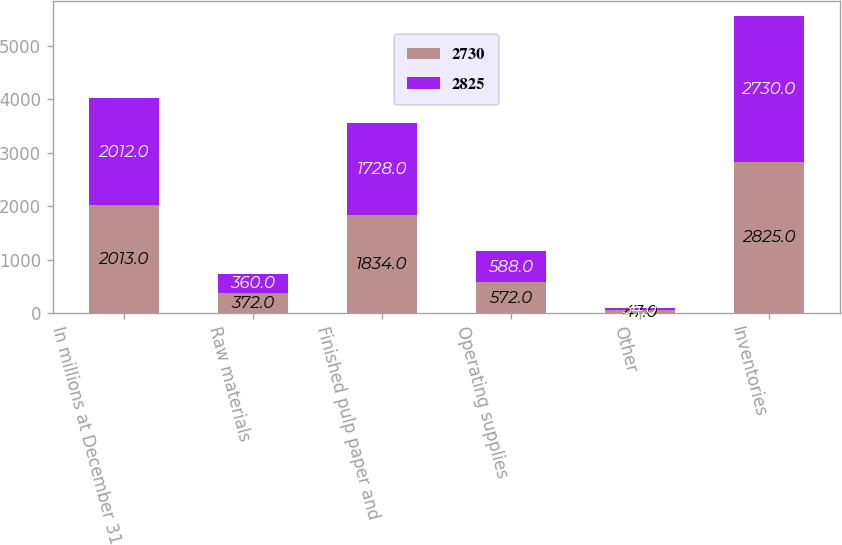Convert chart. <chart><loc_0><loc_0><loc_500><loc_500><stacked_bar_chart><ecel><fcel>In millions at December 31<fcel>Raw materials<fcel>Finished pulp paper and<fcel>Operating supplies<fcel>Other<fcel>Inventories<nl><fcel>2730<fcel>2013<fcel>372<fcel>1834<fcel>572<fcel>47<fcel>2825<nl><fcel>2825<fcel>2012<fcel>360<fcel>1728<fcel>588<fcel>54<fcel>2730<nl></chart> 